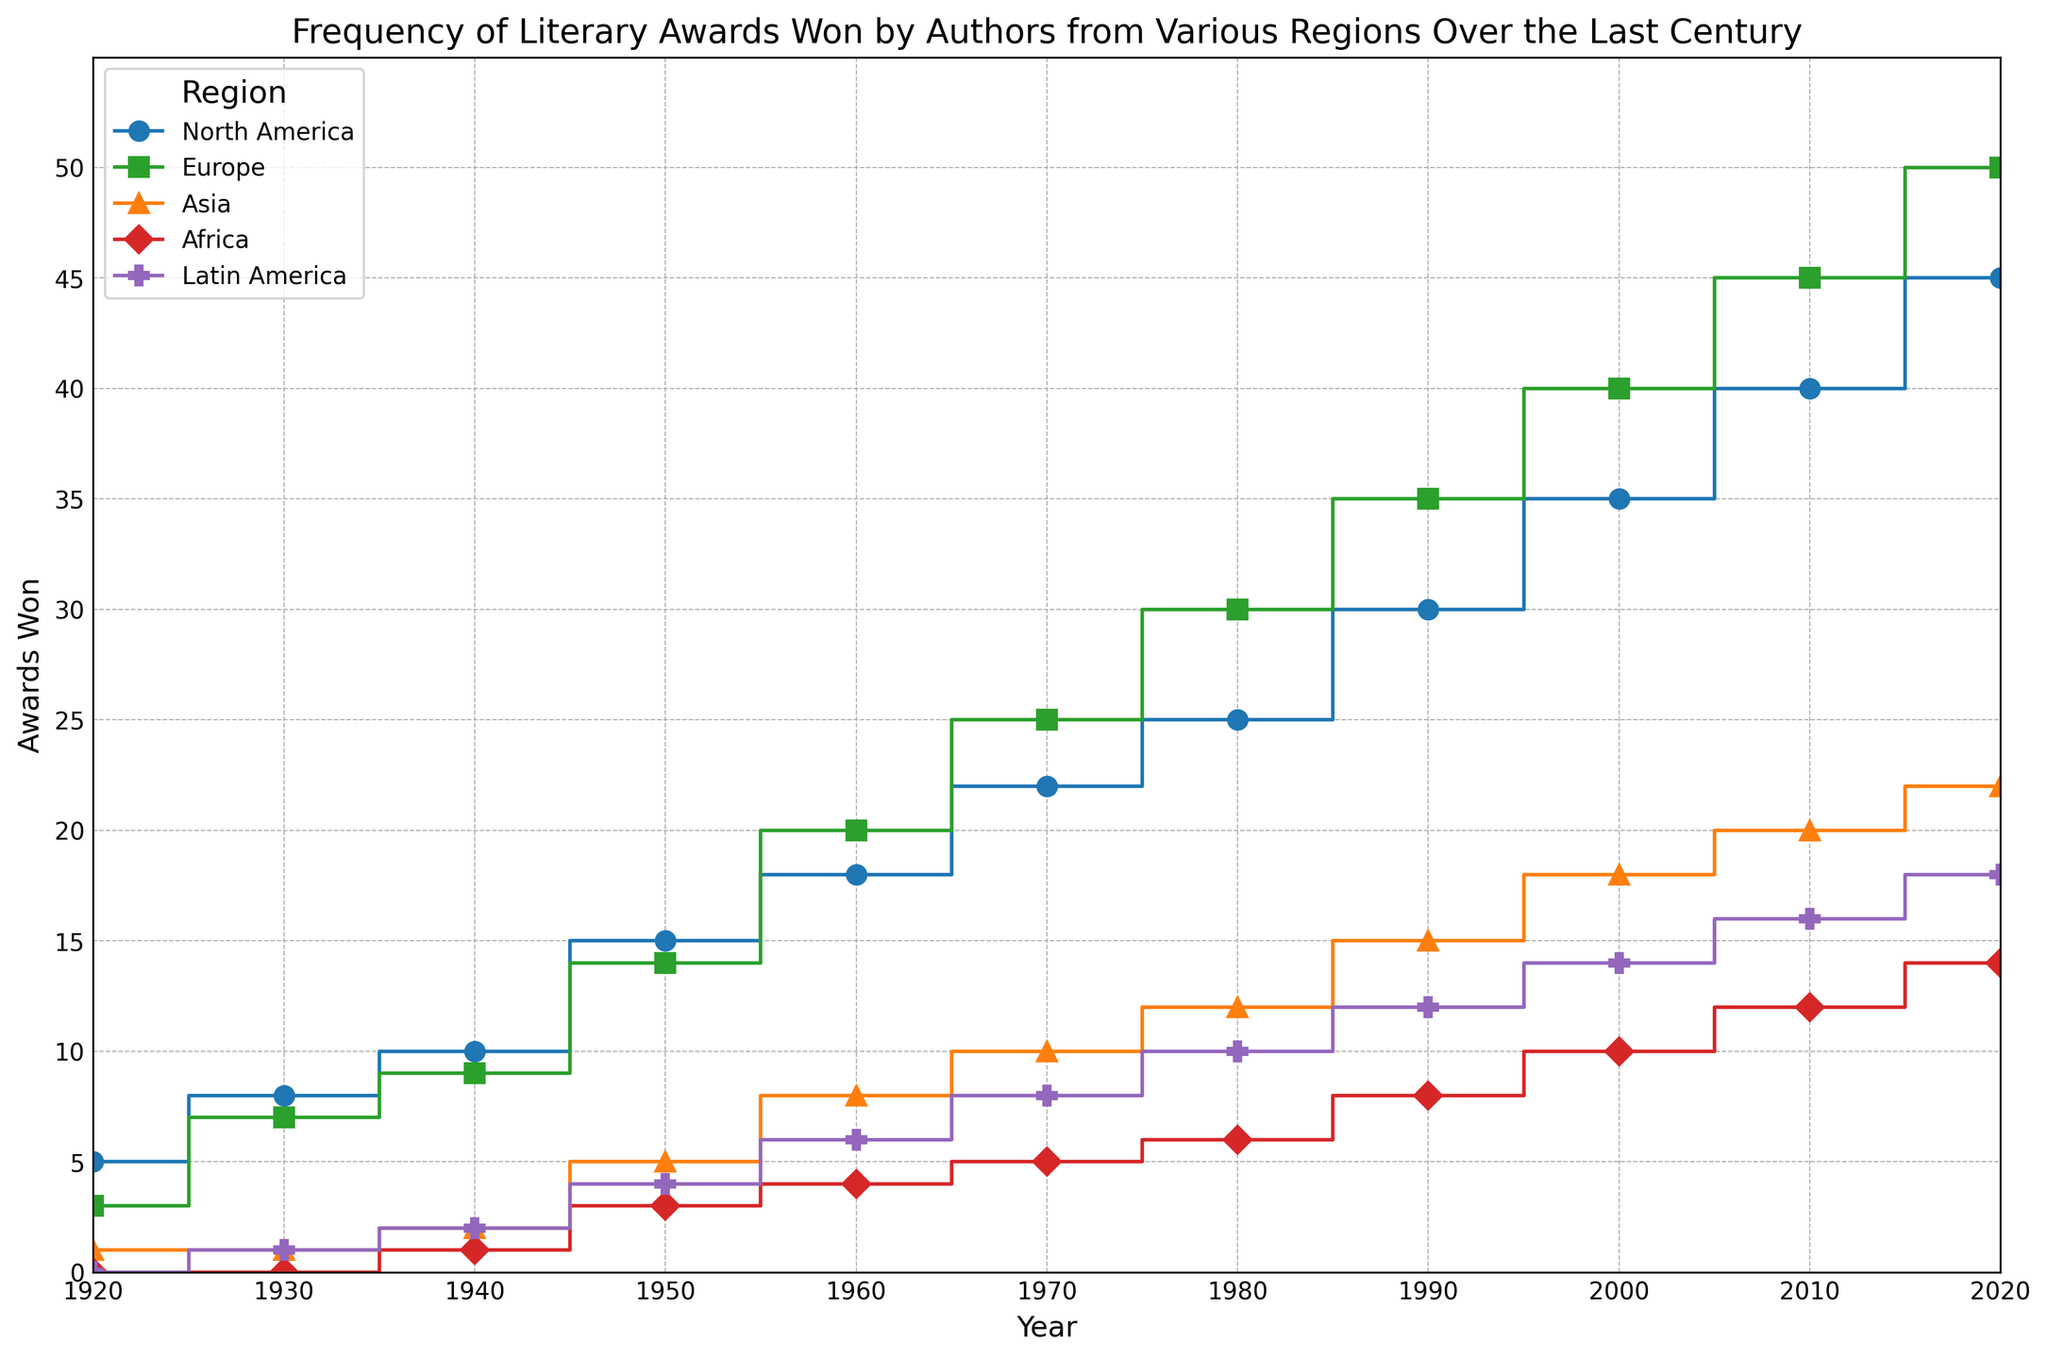Which region won the most literary awards in 2020? Based on the height of the stairs plot for different regions in 2020, Europe has the tallest step, indicating it won the most awards.
Answer: Europe How many more awards did North America win in 2010 compared to 1920? In 2010, North America won 40 awards, and in 1920, it won 5 awards. The difference is 40 - 5 = 35 awards.
Answer: 35 Which years marked a significant increase in literary awards for Latin America? Observe the heights of the steps across different years for Latin America. Noticeable increases occur between the years 1940 (2 awards) to 1950 (4 awards), 1950 to 1960 (6 awards), 1960 to 1970 (8 awards), 1980 to 1990 (10 to 12 awards), and 2000 to 2010 (14 to 16 awards).
Answer: 1940-1950, 1950-1960, 1960-1970, 1980-1990, 2000-2010 By how much did the awards for Asia increase from 1930 to 2020? In 1930, Asia won 1 award, and in 2020, it won 22 awards. The increase is 22 - 1 = 21 awards.
Answer: 21 Which region had the least number of awards in 1960? In 1960, Africa had the least number of awards with 4, as indicated by the shortest step among all regions.
Answer: Africa Compare the total number of awards won by Europe and Asia in 1950. Who won more, and by how much? In 1950, Europe won 14 awards, while Asia won 5 awards. Europe won more by 14 - 5 = 9 awards.
Answer: Europe, by 9 awards What is the pattern of change in awards for North America from 1920 to 2020? The height of the steps for North America shows a steady increase from 5 in 1920 to 45 in 2020, indicating a consistent rise in the number of awards over the century.
Answer: Consistent increase How did the number of awards won by Africa change from 1920 to 2020? In 1920, Africa won 0 awards. The number increased gradually to 14 in 2020, with incremental steps visible in 1940, 1950, 1960, 1970, 1980, 1990, 2000, 2010, and 2020.
Answer: Gradual increase Which region had more awards in 1950: Asia or Latin America, and by how many? In 1950, Asia had 5 awards and Latin America had 4 awards. Asia had 5 - 4 = 1 more award than Latin America.
Answer: Asia, by 1 award What's the overall trend in the awards for Europe compared to other regions? Europe consistently has the highest number of awards throughout the century, with a clear upward trend, surpassing other regions in most of the years.
Answer: Consistently highest and increasing 